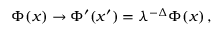<formula> <loc_0><loc_0><loc_500><loc_500>\Phi ( x ) \rightarrow \Phi ^ { \prime } ( x ^ { \prime } ) = \lambda ^ { - \Delta } \Phi ( x ) \, ,</formula> 